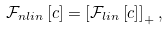Convert formula to latex. <formula><loc_0><loc_0><loc_500><loc_500>\mathcal { F } _ { n l i n } \left [ c \right ] = \left [ \mathcal { F } _ { l i n } \left [ c \right ] \right ] _ { + } ,</formula> 